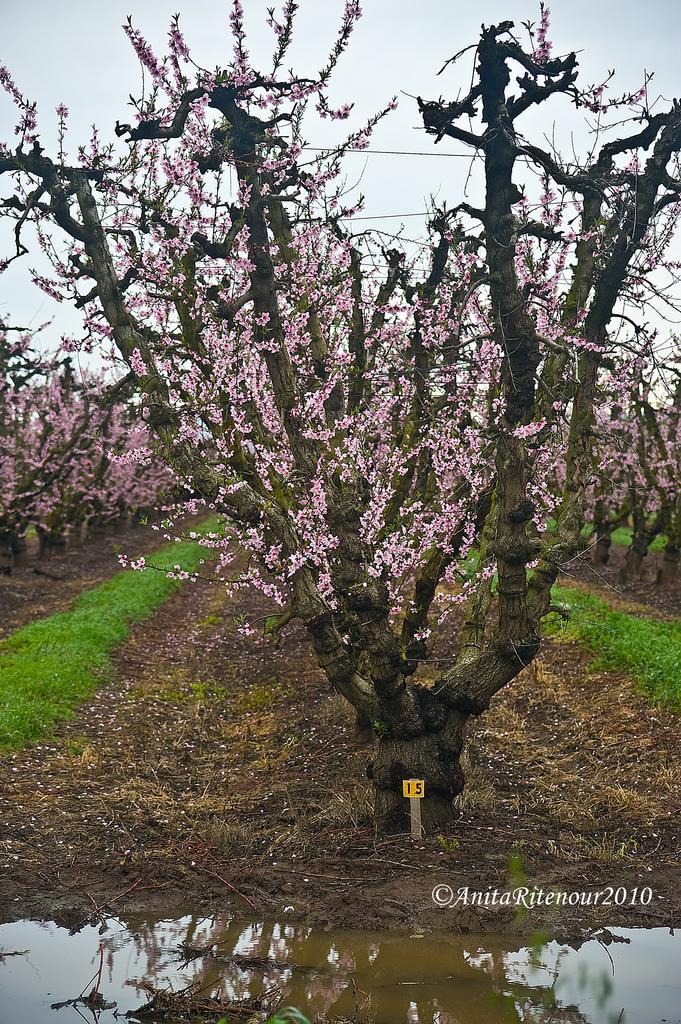Can you describe this image briefly? In this image I see the water over here and I see the ground on which there is grass and I see number of trees on which there are pink colored leaves and I see the clear sky and I see the watermark over here and I see 2 numbers on this yellow color board. 